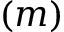Convert formula to latex. <formula><loc_0><loc_0><loc_500><loc_500>( m )</formula> 